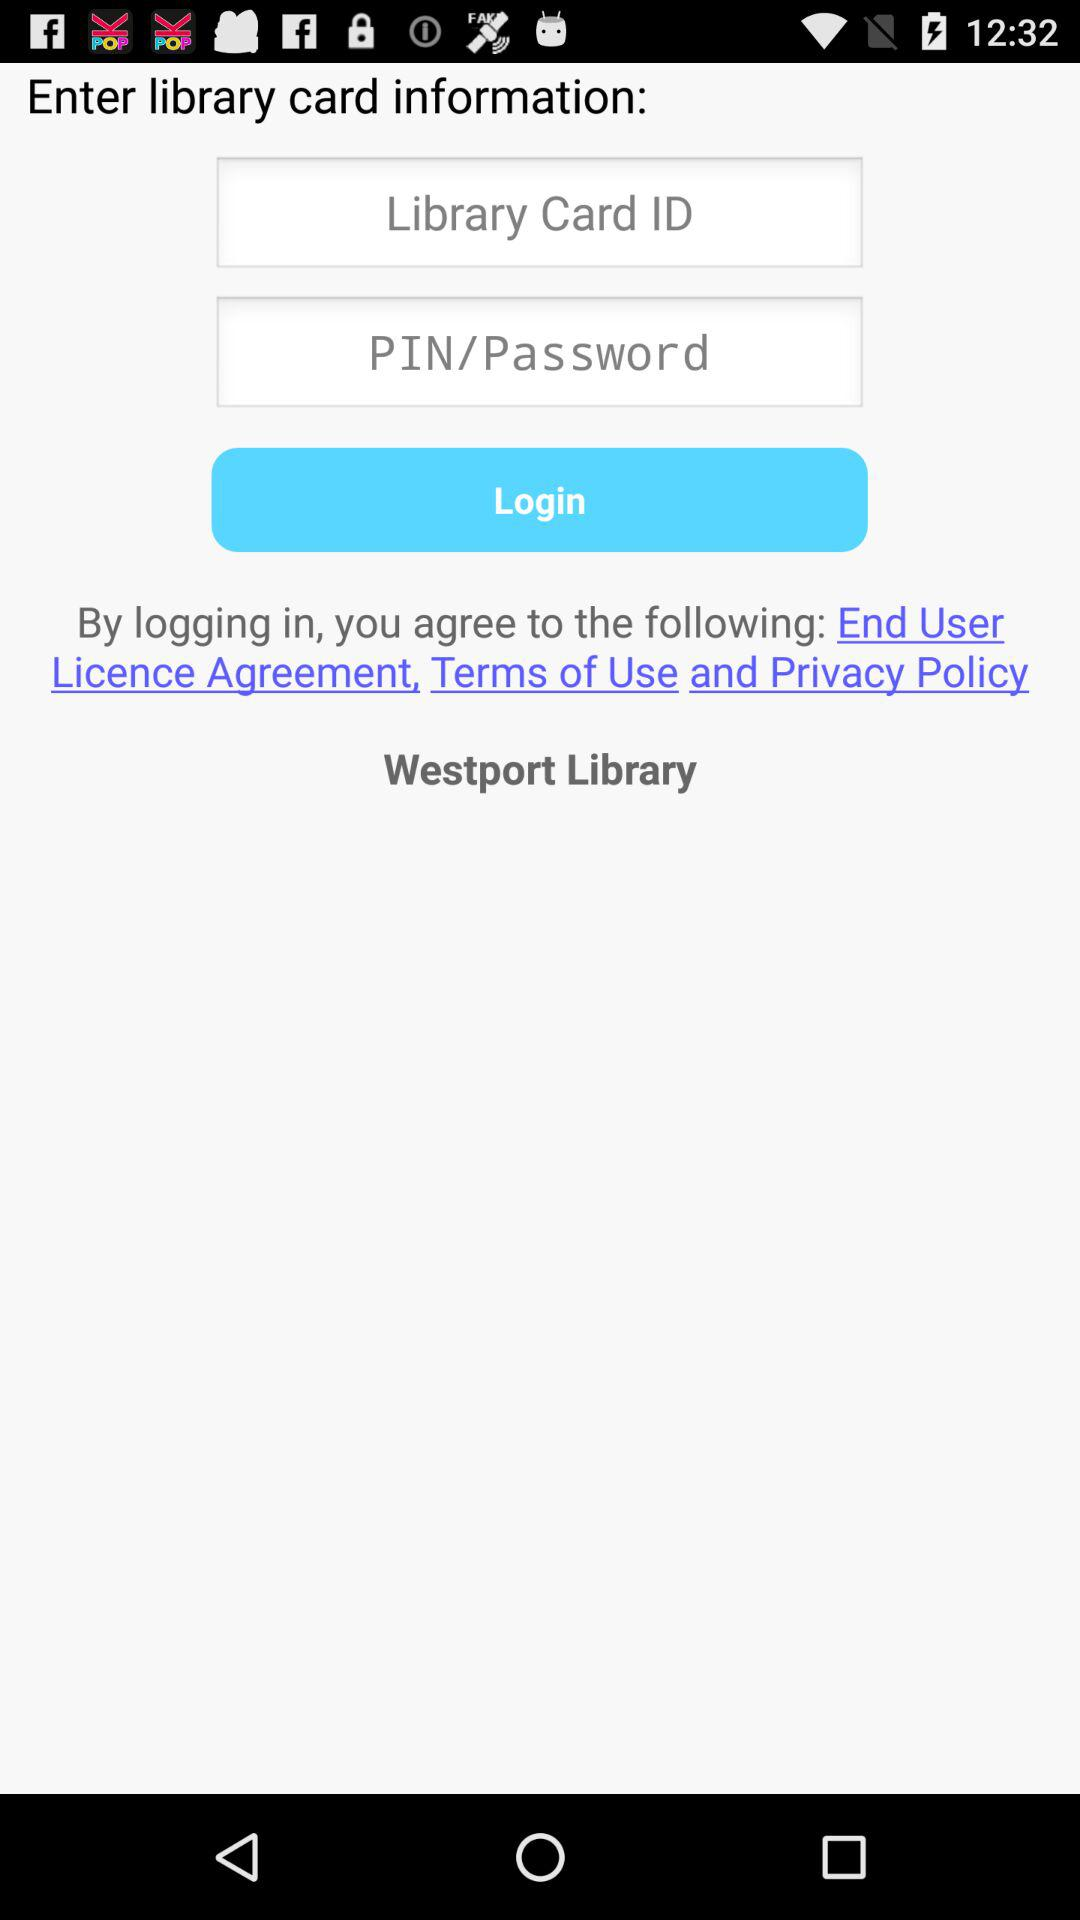What is the application name? The application name is "Westport Library". 